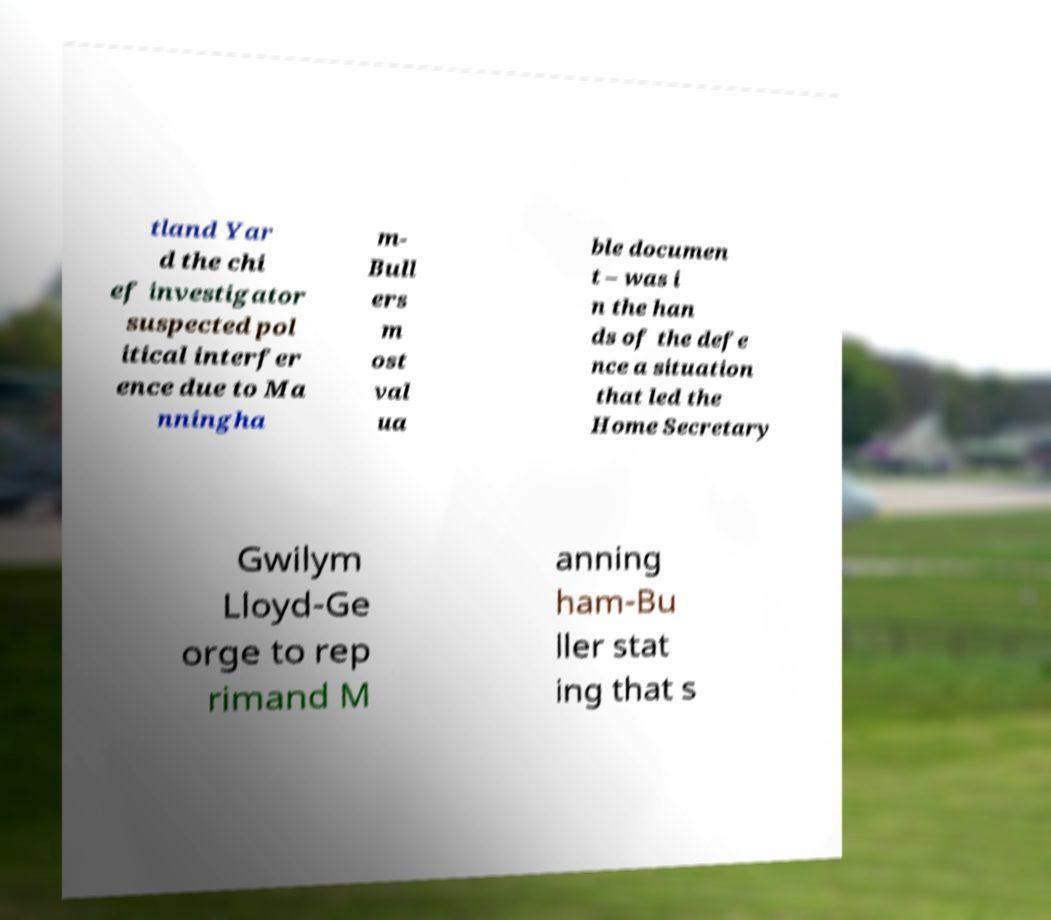For documentation purposes, I need the text within this image transcribed. Could you provide that? tland Yar d the chi ef investigator suspected pol itical interfer ence due to Ma nningha m- Bull ers m ost val ua ble documen t – was i n the han ds of the defe nce a situation that led the Home Secretary Gwilym Lloyd-Ge orge to rep rimand M anning ham-Bu ller stat ing that s 